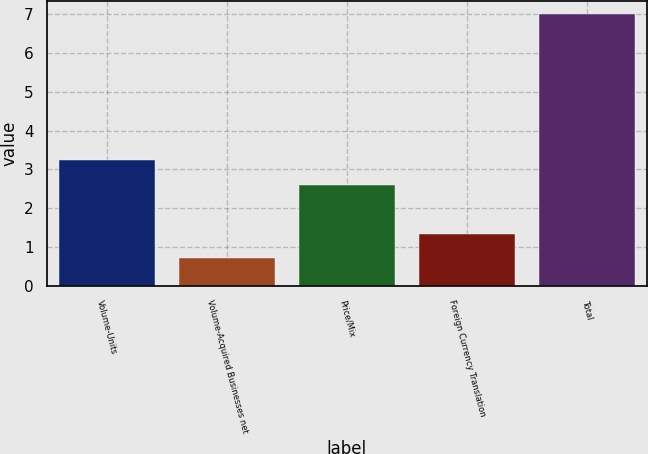<chart> <loc_0><loc_0><loc_500><loc_500><bar_chart><fcel>Volume-Units<fcel>Volume-Acquired Businesses net<fcel>Price/Mix<fcel>Foreign Currency Translation<fcel>Total<nl><fcel>3.23<fcel>0.7<fcel>2.6<fcel>1.33<fcel>7<nl></chart> 